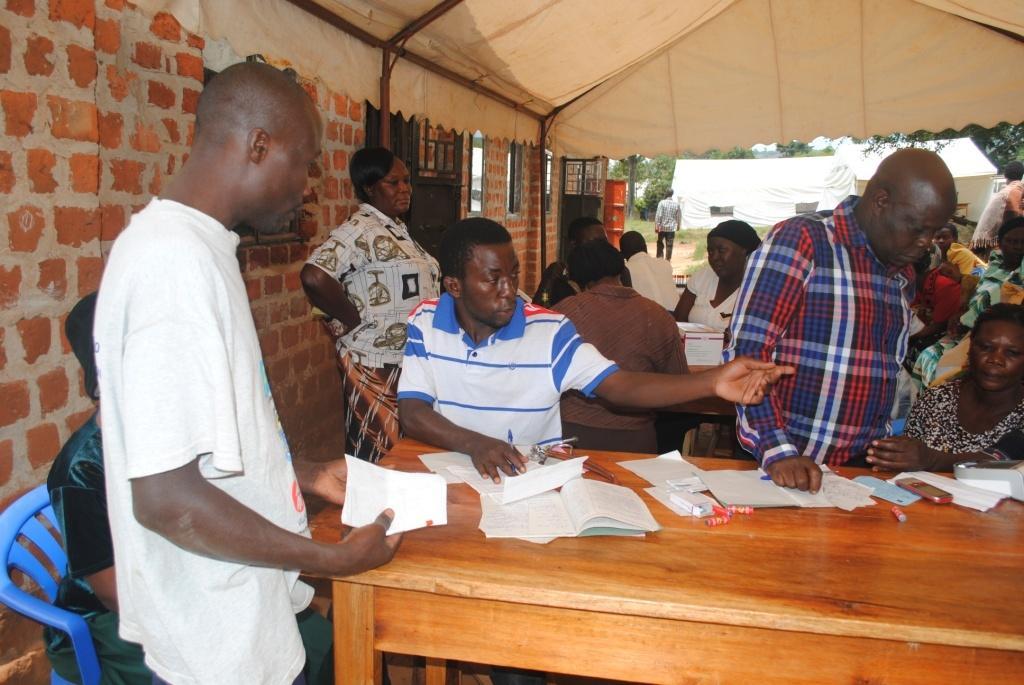Describe this image in one or two sentences. there are people sitting around benches. there are few people standing. on the benches there are papers,books and mobile phone. at the right there is a building with brick wall. at the top there is a tent. behind them there are trees and other tents. 